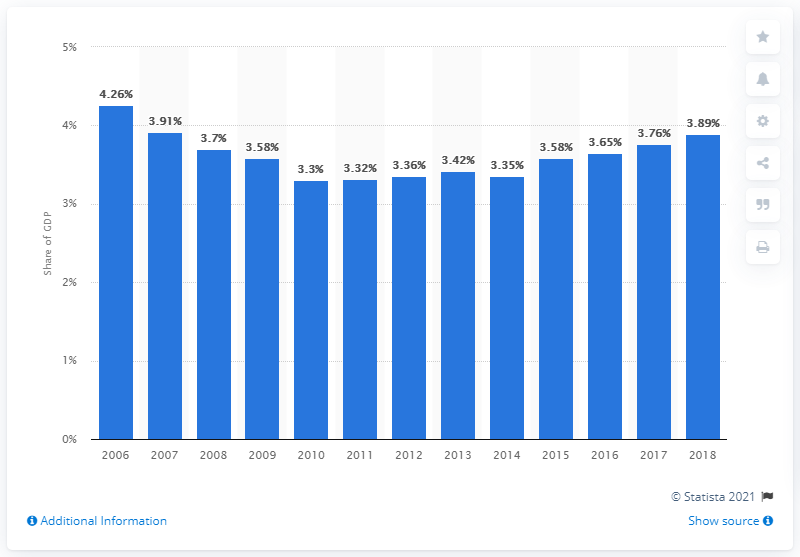Specify some key components in this picture. In 2018, approximately 3.89% of Nigeria's Gross Domestic Product (GDP) was allocated towards health expenditure. 